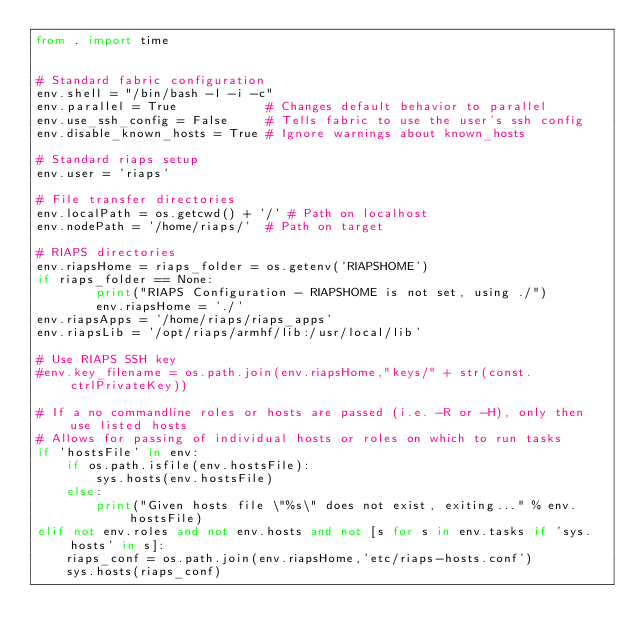<code> <loc_0><loc_0><loc_500><loc_500><_Python_>from . import time


# Standard fabric configuration
env.shell = "/bin/bash -l -i -c"
env.parallel = True            # Changes default behavior to parallel
env.use_ssh_config = False     # Tells fabric to use the user's ssh config
env.disable_known_hosts = True # Ignore warnings about known_hosts

# Standard riaps setup
env.user = 'riaps'

# File transfer directories
env.localPath = os.getcwd() + '/' # Path on localhost
env.nodePath = '/home/riaps/'  # Path on target

# RIAPS directories
env.riapsHome = riaps_folder = os.getenv('RIAPSHOME')
if riaps_folder == None:
        print("RIAPS Configuration - RIAPSHOME is not set, using ./")
        env.riapsHome = './'
env.riapsApps = '/home/riaps/riaps_apps'
env.riapsLib = '/opt/riaps/armhf/lib:/usr/local/lib'

# Use RIAPS SSH key
#env.key_filename = os.path.join(env.riapsHome,"keys/" + str(const.ctrlPrivateKey))

# If a no commandline roles or hosts are passed (i.e. -R or -H), only then use listed hosts
# Allows for passing of individual hosts or roles on which to run tasks
if 'hostsFile' in env:
    if os.path.isfile(env.hostsFile):
        sys.hosts(env.hostsFile)
    else:
        print("Given hosts file \"%s\" does not exist, exiting..." % env.hostsFile)
elif not env.roles and not env.hosts and not [s for s in env.tasks if 'sys.hosts' in s]:
    riaps_conf = os.path.join(env.riapsHome,'etc/riaps-hosts.conf')
    sys.hosts(riaps_conf)
</code> 